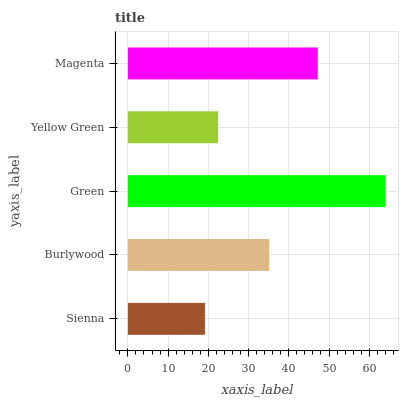Is Sienna the minimum?
Answer yes or no. Yes. Is Green the maximum?
Answer yes or no. Yes. Is Burlywood the minimum?
Answer yes or no. No. Is Burlywood the maximum?
Answer yes or no. No. Is Burlywood greater than Sienna?
Answer yes or no. Yes. Is Sienna less than Burlywood?
Answer yes or no. Yes. Is Sienna greater than Burlywood?
Answer yes or no. No. Is Burlywood less than Sienna?
Answer yes or no. No. Is Burlywood the high median?
Answer yes or no. Yes. Is Burlywood the low median?
Answer yes or no. Yes. Is Yellow Green the high median?
Answer yes or no. No. Is Yellow Green the low median?
Answer yes or no. No. 